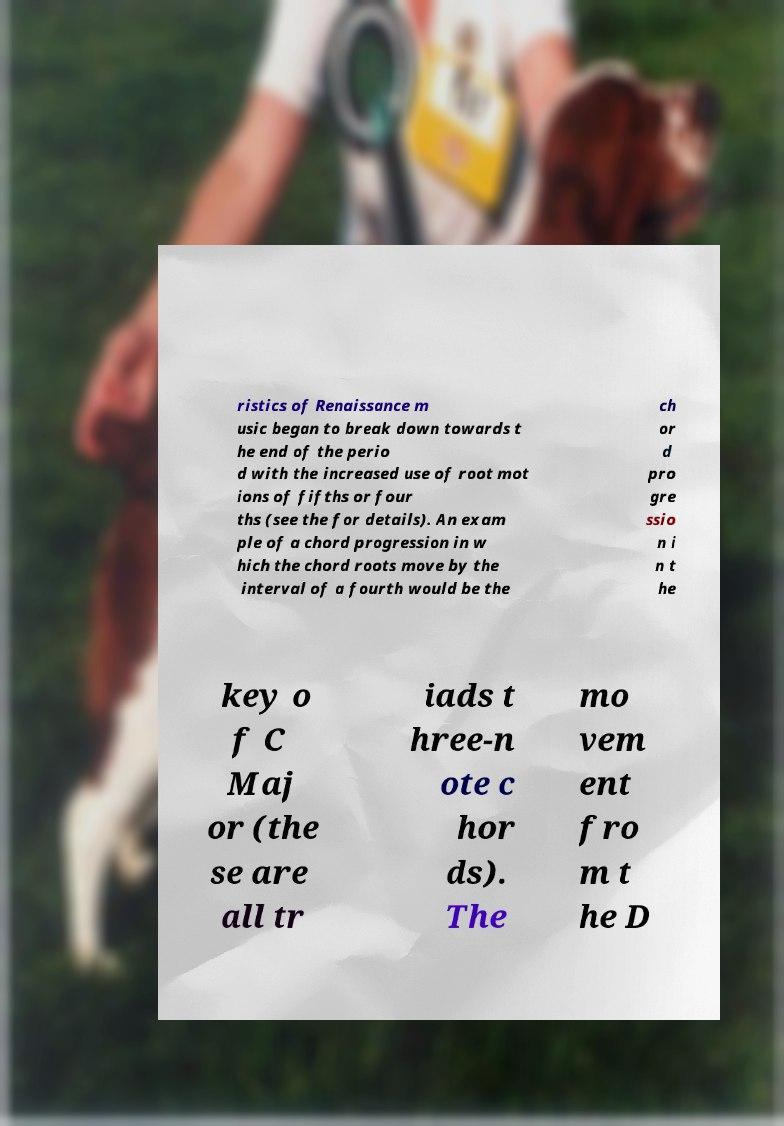What messages or text are displayed in this image? I need them in a readable, typed format. ristics of Renaissance m usic began to break down towards t he end of the perio d with the increased use of root mot ions of fifths or four ths (see the for details). An exam ple of a chord progression in w hich the chord roots move by the interval of a fourth would be the ch or d pro gre ssio n i n t he key o f C Maj or (the se are all tr iads t hree-n ote c hor ds). The mo vem ent fro m t he D 